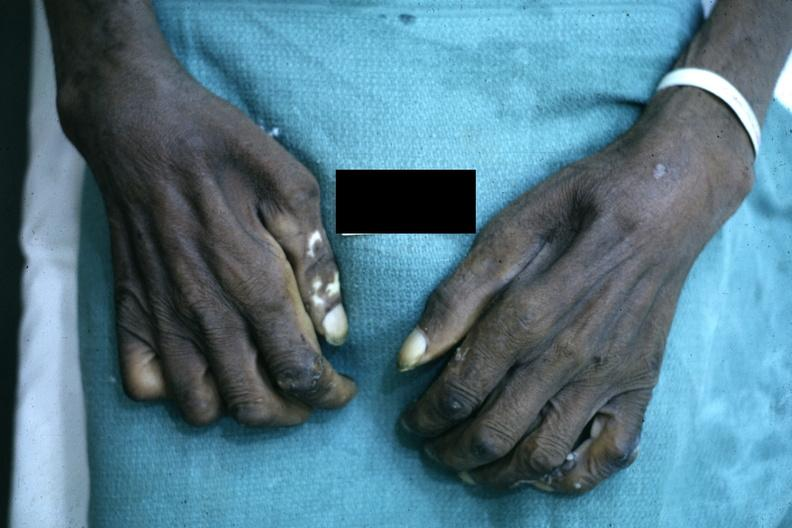re extremities present?
Answer the question using a single word or phrase. Yes 